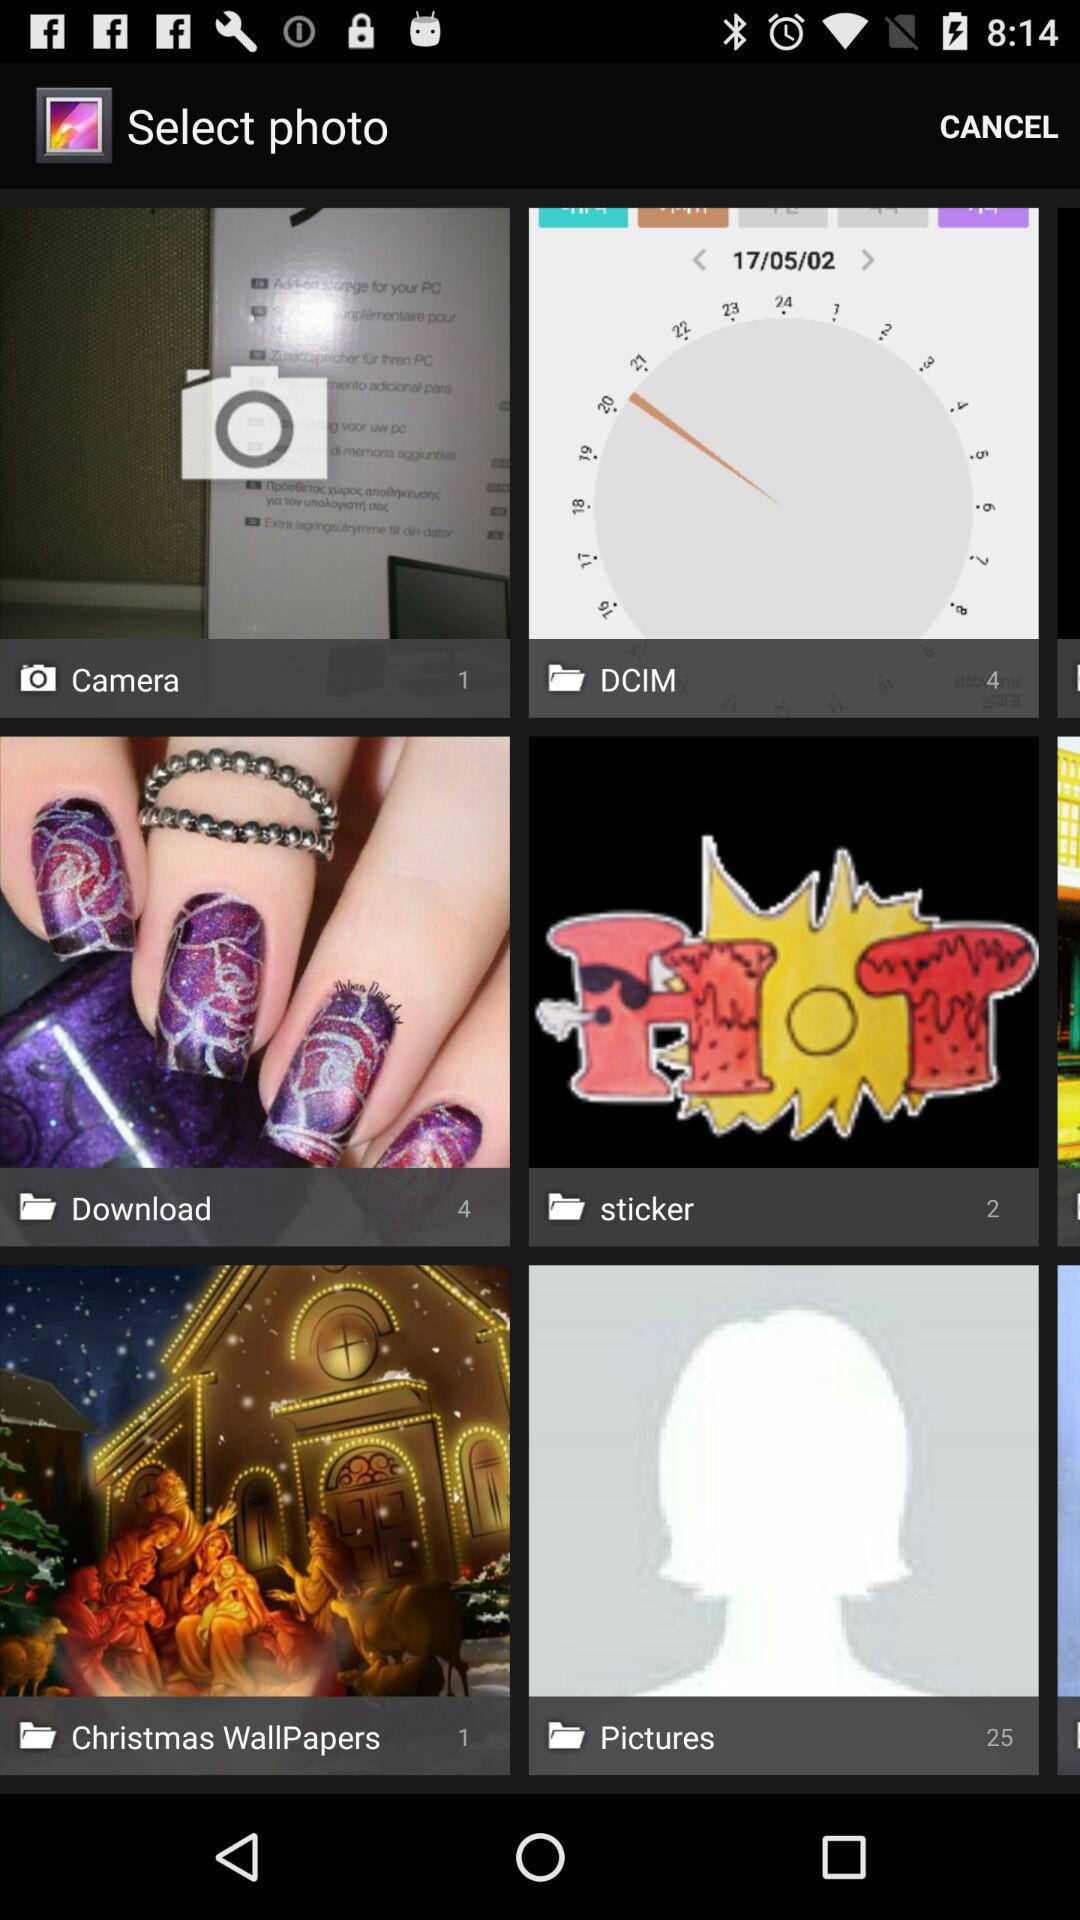How many more items are in the Pictures album than the DCIM album?
Answer the question using a single word or phrase. 21 